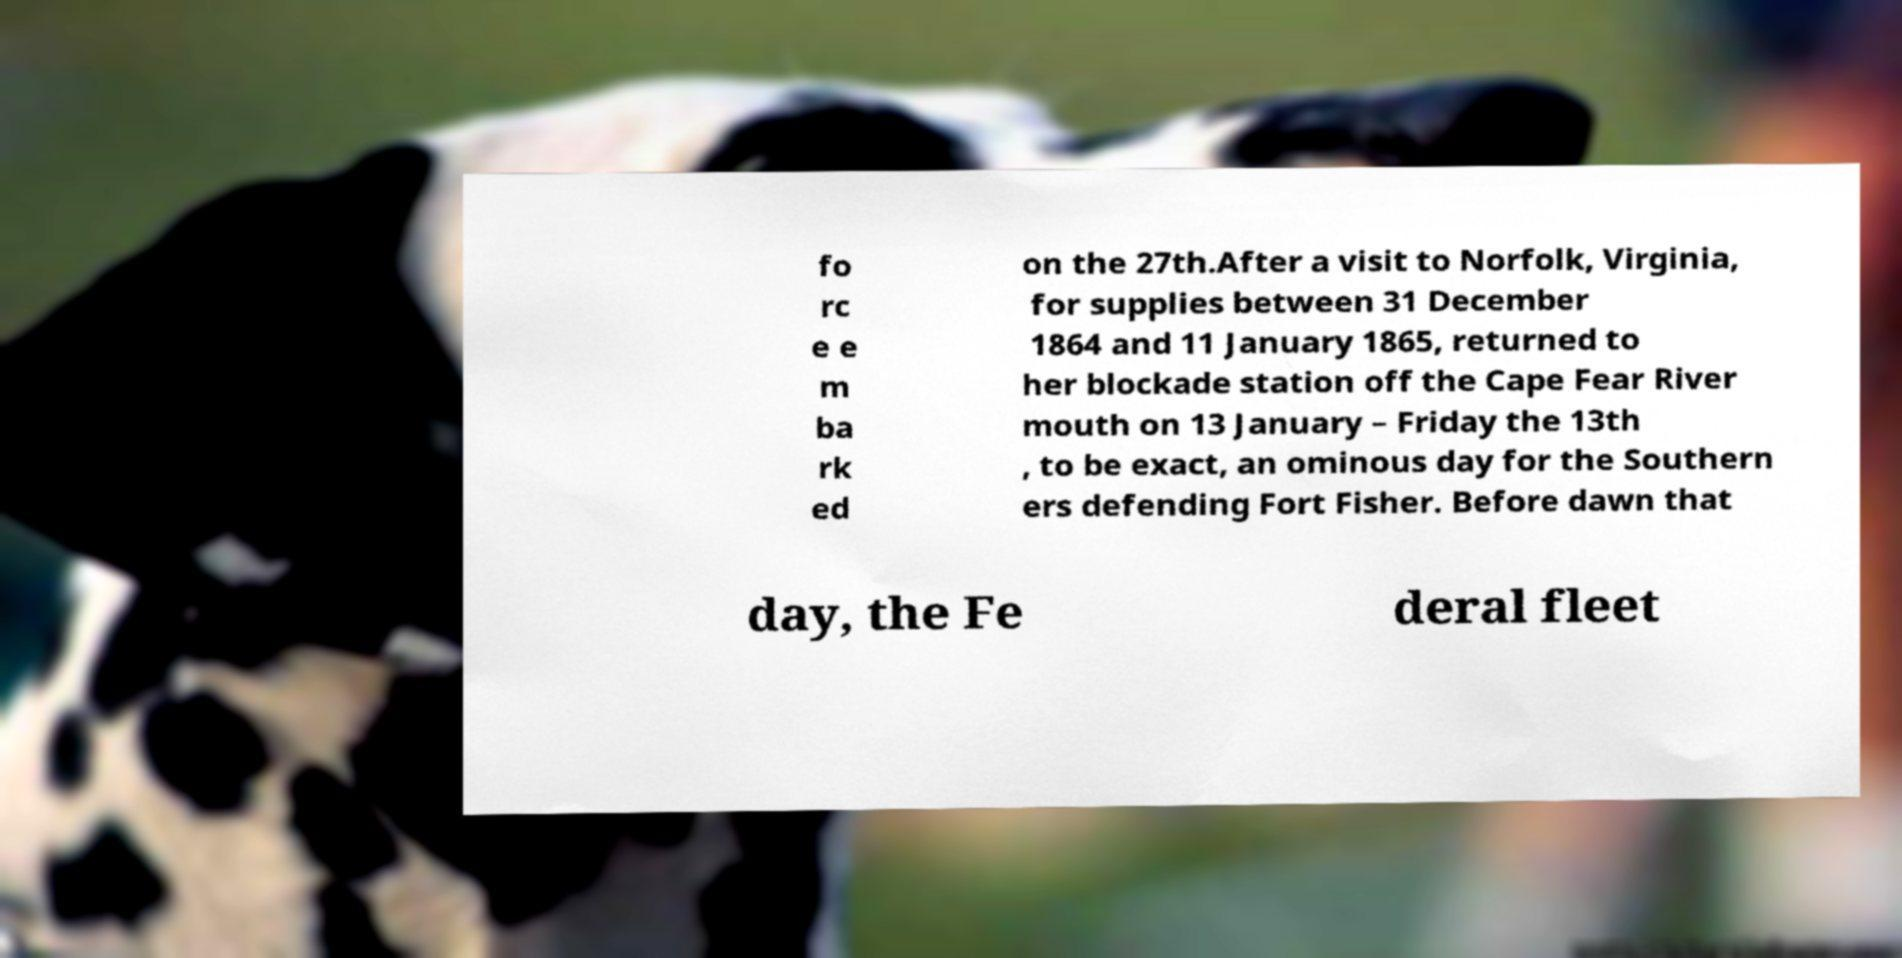I need the written content from this picture converted into text. Can you do that? fo rc e e m ba rk ed on the 27th.After a visit to Norfolk, Virginia, for supplies between 31 December 1864 and 11 January 1865, returned to her blockade station off the Cape Fear River mouth on 13 January – Friday the 13th , to be exact, an ominous day for the Southern ers defending Fort Fisher. Before dawn that day, the Fe deral fleet 